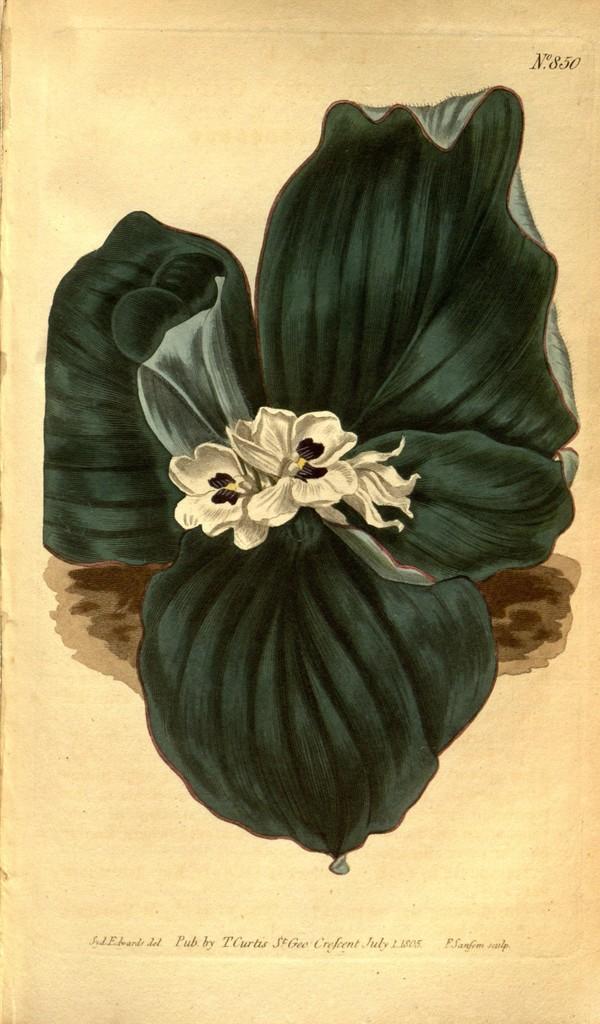Please provide a concise description of this image. In this image there is a paper with a depiction of a plant and flowers on it and there is a text on the paper. 